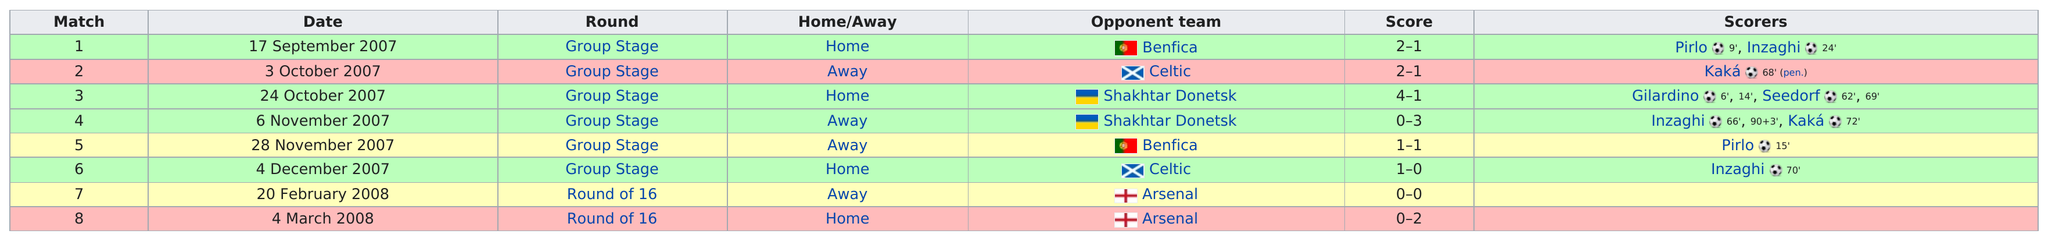Specify some key components in this picture. On October 24th, 2007, a team scored 4 points. The opponent team, Shakhtar Donetsk, was defeated consecutively for two times. On November 6, 2007, the 4th match took place, with the away team emerging victorious. A.C. Milan played its first match in the UEFA Champions League against the team Benfica. The game was won by the team that was the top performer, whether it was played at home or away. 